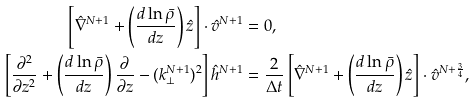Convert formula to latex. <formula><loc_0><loc_0><loc_500><loc_500>\left [ \hat { \nabla } ^ { N + 1 } + \left ( \frac { d \ln \bar { \rho } } { d z } \right ) \hat { z } \right ] \cdot \hat { v } ^ { N + 1 } & = 0 , \\ \left [ \frac { \partial ^ { 2 } } { \partial z ^ { 2 } } + \left ( \frac { d \ln \bar { \rho } } { d z } \right ) \frac { \partial } { \partial z } - ( k _ { \bot } ^ { N + 1 } ) ^ { 2 } \right ] \hat { h } ^ { N + 1 } & = \frac { 2 } { \Delta t } \left [ \hat { \nabla } ^ { N + 1 } + \left ( \frac { d \ln \bar { \rho } } { d z } \right ) \hat { z } \right ] \cdot \hat { v } ^ { N + \frac { 3 } { 4 } } ,</formula> 